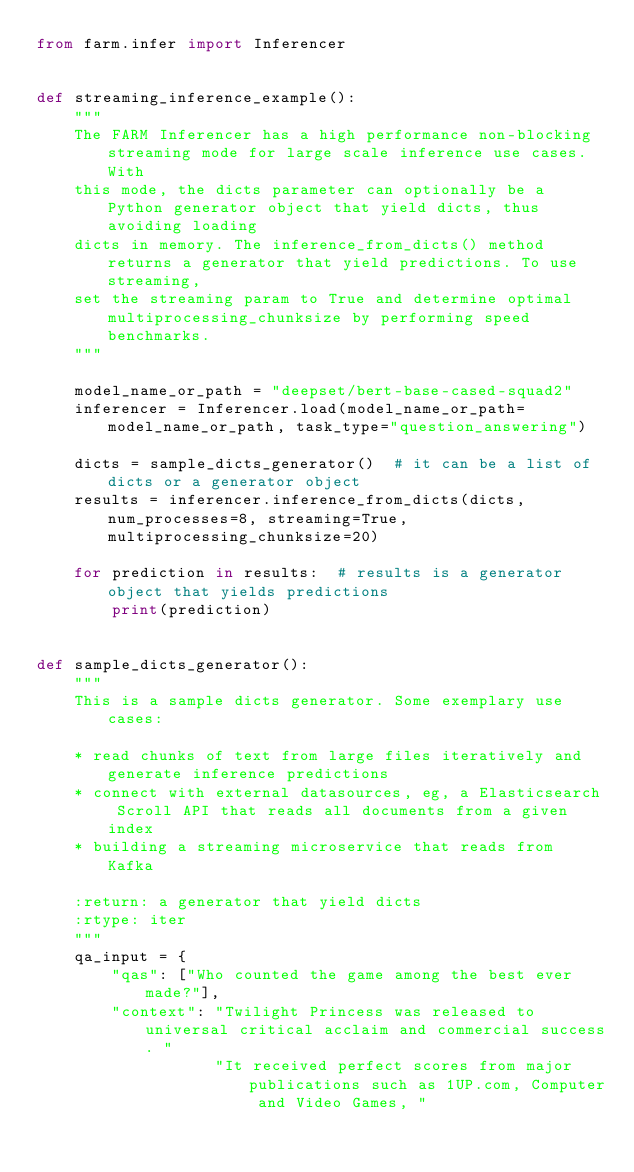Convert code to text. <code><loc_0><loc_0><loc_500><loc_500><_Python_>from farm.infer import Inferencer


def streaming_inference_example():
    """
    The FARM Inferencer has a high performance non-blocking streaming mode for large scale inference use cases. With
    this mode, the dicts parameter can optionally be a Python generator object that yield dicts, thus avoiding loading
    dicts in memory. The inference_from_dicts() method returns a generator that yield predictions. To use streaming,
    set the streaming param to True and determine optimal multiprocessing_chunksize by performing speed benchmarks.
    """

    model_name_or_path = "deepset/bert-base-cased-squad2"
    inferencer = Inferencer.load(model_name_or_path=model_name_or_path, task_type="question_answering")

    dicts = sample_dicts_generator()  # it can be a list of dicts or a generator object
    results = inferencer.inference_from_dicts(dicts, num_processes=8, streaming=True, multiprocessing_chunksize=20)

    for prediction in results:  # results is a generator object that yields predictions
        print(prediction)


def sample_dicts_generator():
    """
    This is a sample dicts generator. Some exemplary use cases:

    * read chunks of text from large files iteratively and generate inference predictions
    * connect with external datasources, eg, a Elasticsearch Scroll API that reads all documents from a given index
    * building a streaming microservice that reads from Kafka

    :return: a generator that yield dicts
    :rtype: iter
    """
    qa_input = {
        "qas": ["Who counted the game among the best ever made?"],
        "context": "Twilight Princess was released to universal critical acclaim and commercial success. "
                   "It received perfect scores from major publications such as 1UP.com, Computer and Video Games, "</code> 